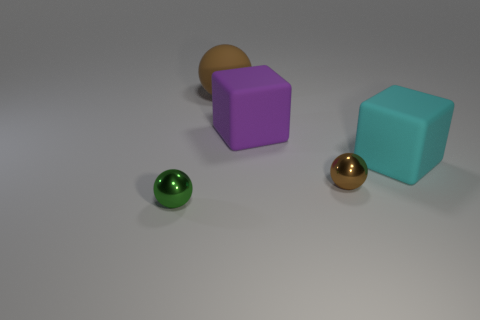Add 1 large yellow metallic blocks. How many objects exist? 6 Subtract all brown balls. How many balls are left? 1 Subtract all purple cubes. How many brown spheres are left? 2 Subtract all brown balls. How many balls are left? 1 Subtract all balls. How many objects are left? 2 Subtract all blue balls. Subtract all brown cylinders. How many balls are left? 3 Subtract all small purple metal balls. Subtract all rubber cubes. How many objects are left? 3 Add 2 brown things. How many brown things are left? 4 Add 5 green cylinders. How many green cylinders exist? 5 Subtract 0 purple cylinders. How many objects are left? 5 